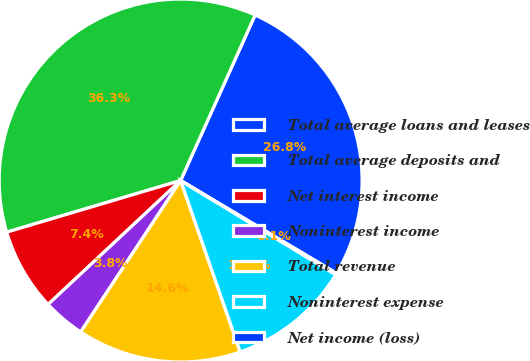Convert chart to OTSL. <chart><loc_0><loc_0><loc_500><loc_500><pie_chart><fcel>Total average loans and leases<fcel>Total average deposits and<fcel>Net interest income<fcel>Noninterest income<fcel>Total revenue<fcel>Noninterest expense<fcel>Net income (loss)<nl><fcel>26.81%<fcel>36.32%<fcel>7.37%<fcel>3.75%<fcel>14.61%<fcel>10.99%<fcel>0.14%<nl></chart> 